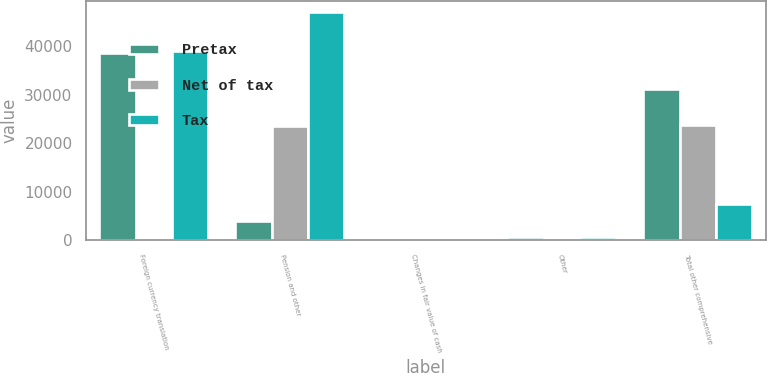Convert chart. <chart><loc_0><loc_0><loc_500><loc_500><stacked_bar_chart><ecel><fcel>Foreign currency translation<fcel>Pension and other<fcel>Changes in fair value of cash<fcel>Other<fcel>Total other comprehensive<nl><fcel>Pretax<fcel>38521<fcel>4044<fcel>195<fcel>692<fcel>31234<nl><fcel>Net of tax<fcel>359<fcel>23632<fcel>70<fcel>83<fcel>23838<nl><fcel>Tax<fcel>38880<fcel>47010<fcel>125<fcel>609<fcel>7396<nl></chart> 